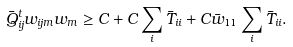Convert formula to latex. <formula><loc_0><loc_0><loc_500><loc_500>\bar { Q } ^ { t } _ { i j } w _ { i j m } w _ { m } & \geq C + C \sum _ { i } \bar { T } _ { i i } + C \bar { w } _ { 1 1 } \sum _ { i } \bar { T } _ { i i } .</formula> 